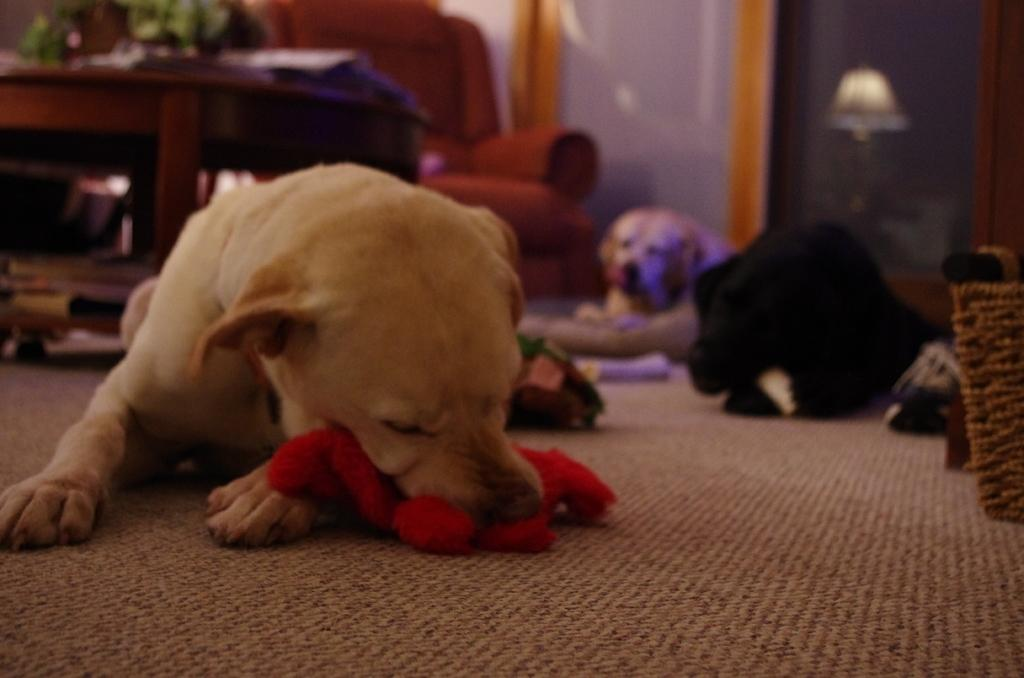What animals are laying on the floor in the image? There are dogs laying on the floor in the image. What type of furniture is present in the image? There is a sofa and a table in the image. Where is the lamp located in the image? The lamp is on the right side in the image. What type of gold jewelry is the friend wearing in the image? There is no friend or gold jewelry present in the image. What type of building can be seen in the background of the image? There is no building visible in the image; it only features dogs, a sofa, a table, and a lamp. 